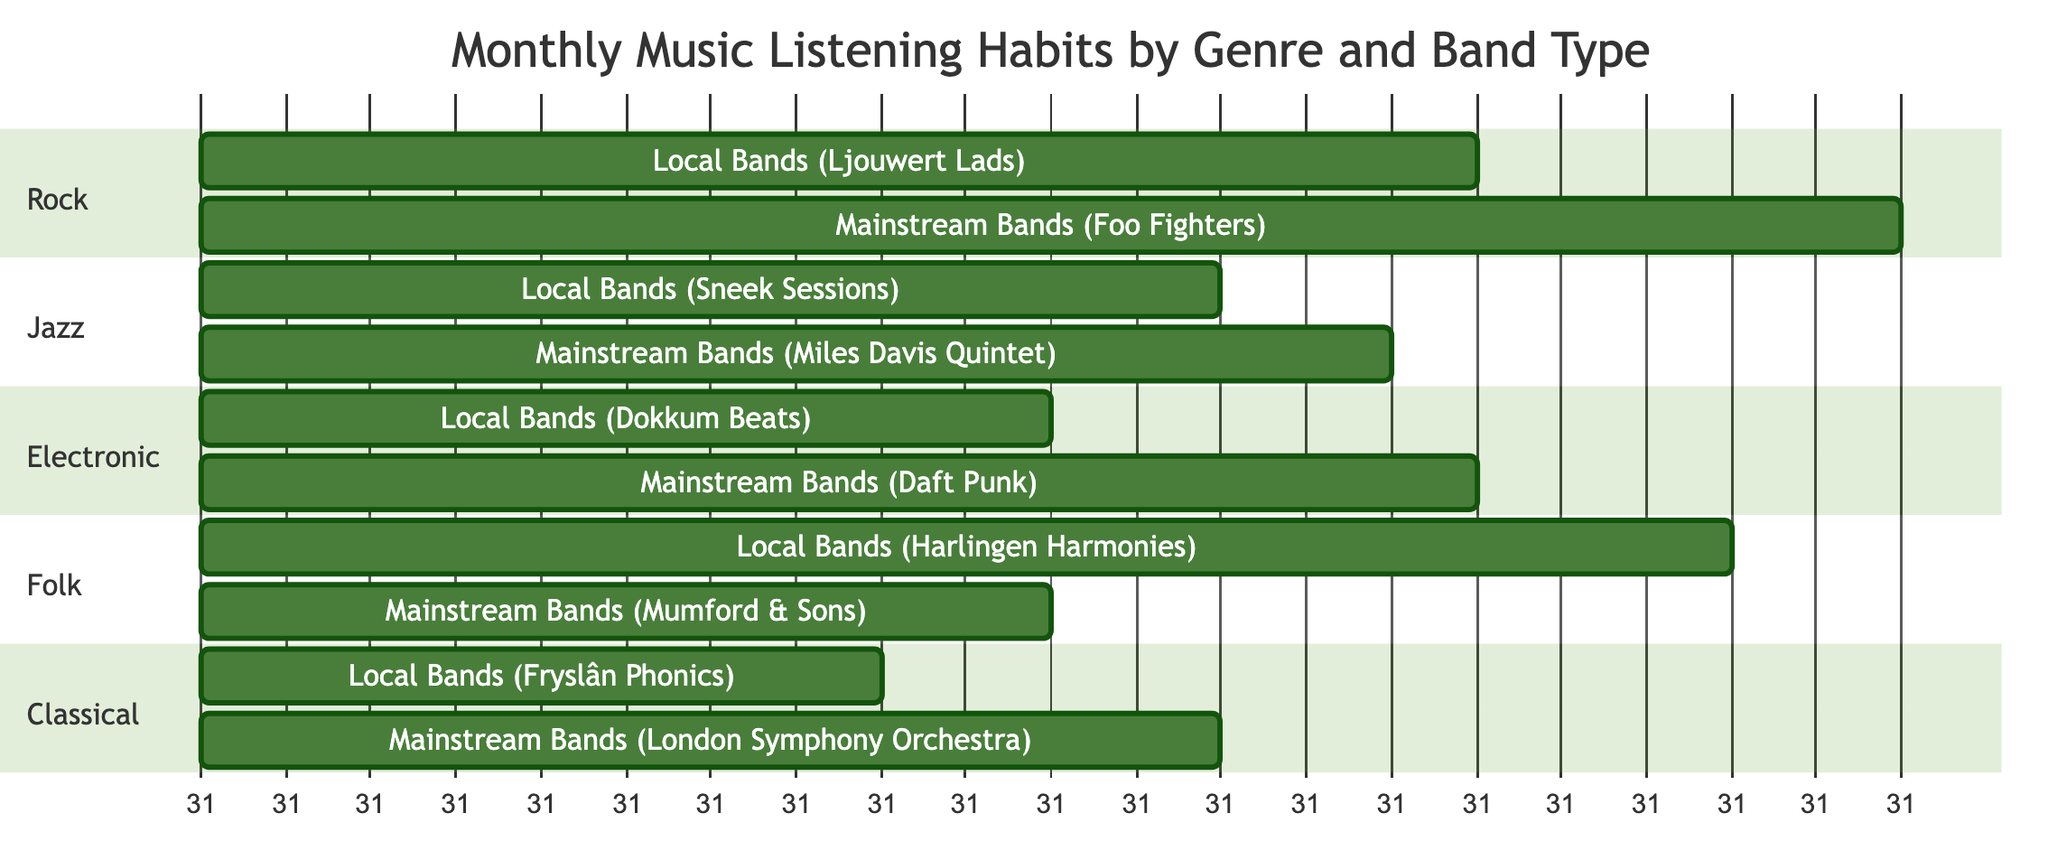What's the total listening time for local bands in the Rock genre? From the diagram, the local bands in the Rock genre (Ljouwert Lads) have a listening time of 15 hours.
Answer: 15 What is the total listening time for mainstream bands in the Jazz genre? The diagram shows that the mainstream bands in the Jazz genre (Miles Davis Quintet) have a listening time of 14 hours.
Answer: 14 Which genre has the highest total listening time for local bands? By comparing the listening times for local bands across genres, Folk (Harlingen Harmonies) has the highest listening time of 18 hours.
Answer: Folk How many hours do you spend listening to mainstream bands in Electronic compared to local bands? The mainstream bands in Electronic (Daft Punk) have a listening time of 15 hours, while the local bands (Dokkum Beats) have 10 hours. The difference is 15 - 10 = 5 hours more for mainstream bands.
Answer: 5 What is the total listening time for Classical genre bands? Summing the listening times for both local (Fryslân Phonics, 8 hours) and mainstream (London Symphony Orchestra, 12 hours) bands, the total for the Classical genre is 8 + 12 = 20 hours.
Answer: 20 Which genre has the largest difference in listening hours between local and mainstream bands? Analyzing the different genres, Rock has 20 - 15 = 5 hours difference, Jazz has 14 - 12 = 2 hours difference, Electronic has 15 - 10 = 5 hours difference, Folk has 18 - 10 = 8 hours difference, and Classical has 12 - 8 = 4 hours difference. The largest difference is in Folk with 8 hours.
Answer: Folk What is the average listening time for local bands across all genres? Adding the local band hours: 15 (Rock) + 12 (Jazz) + 10 (Electronic) + 18 (Folk) + 8 (Classical) = 63 hours. Dividing by 5 genres, the average is 63 / 5 = 12.6 hours.
Answer: 12.6 What percentage of the total listening time in the Jazz genre is spent on mainstream bands? The total listening time for Jazz is 12 (local) + 14 (mainstream) = 26 hours. The mainstream listening time is 14, thus the percentage is (14 / 26) * 100 ≈ 53.85%.
Answer: 53.85% 